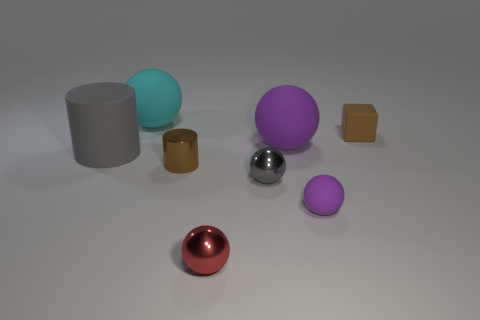Subtract all purple rubber spheres. How many spheres are left? 3 Add 1 big yellow rubber cylinders. How many objects exist? 9 Subtract all purple spheres. How many spheres are left? 3 Subtract 1 blocks. How many blocks are left? 0 Subtract all purple blocks. How many brown cylinders are left? 1 Subtract all tiny yellow rubber blocks. Subtract all brown rubber blocks. How many objects are left? 7 Add 5 small red shiny things. How many small red shiny things are left? 6 Add 4 large green spheres. How many large green spheres exist? 4 Subtract 0 yellow spheres. How many objects are left? 8 Subtract all balls. How many objects are left? 3 